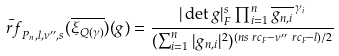<formula> <loc_0><loc_0><loc_500><loc_500>& \bar { \ r f } _ { P _ { n } , l , \nu ^ { \prime \prime } , s } ( \overline { \xi _ { Q ( \gamma ) } } ) ( g ) = \frac { | \det g | _ { F } ^ { s } \prod _ { i = 1 } ^ { n } \overline { g _ { n , i } } ^ { \, \gamma _ { i } } } { ( \sum _ { i = 1 } ^ { n } | g _ { n , i } | ^ { 2 } ) ^ { ( n s \ r c _ { F } - \nu ^ { \prime \prime } \ r c _ { F } - l ) / 2 } }</formula> 